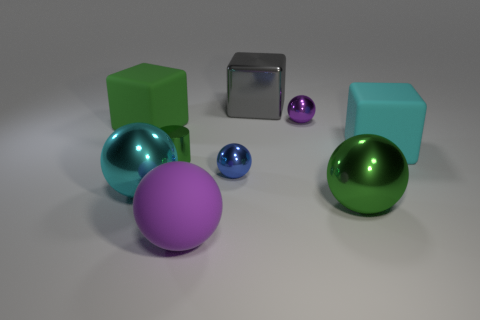Subtract all big rubber spheres. How many spheres are left? 4 Subtract all green balls. How many balls are left? 4 Subtract all cyan spheres. Subtract all red cylinders. How many spheres are left? 4 Subtract all cubes. How many objects are left? 6 Subtract 1 blue spheres. How many objects are left? 8 Subtract all small purple metallic balls. Subtract all blue balls. How many objects are left? 7 Add 9 large purple rubber things. How many large purple rubber things are left? 10 Add 3 large gray matte balls. How many large gray matte balls exist? 3 